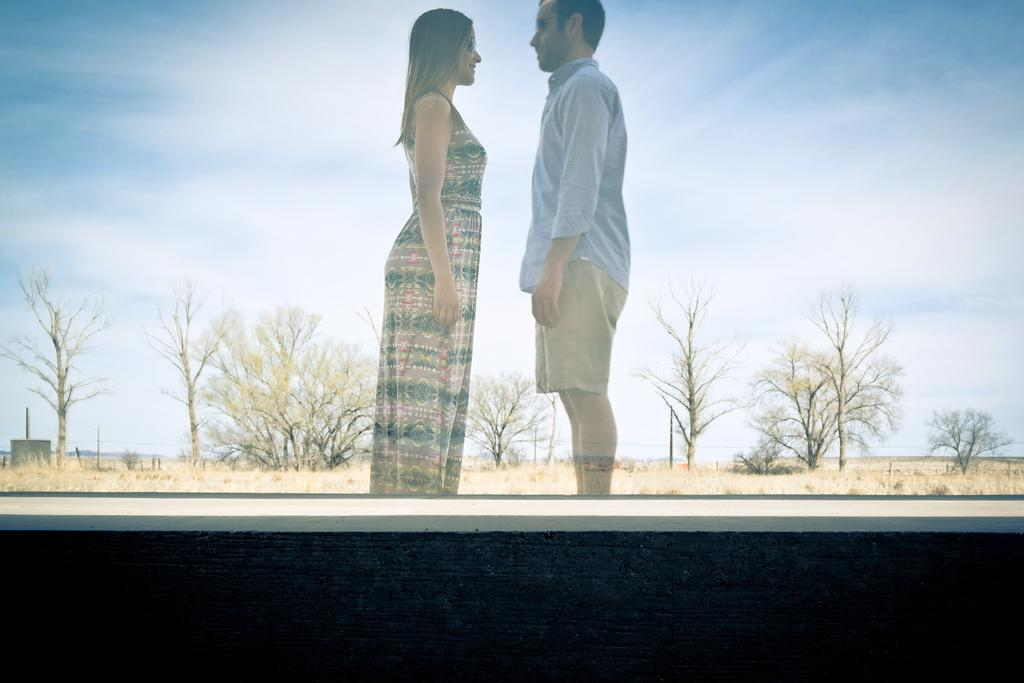Who can be seen in the picture? There is a couple in the picture. What is the couple's position in the image? The couple is standing on the ground. What can be seen in the background of the image? There are trees and the sky visible in the background of the image. What is the condition of the sky in the image? The sky has clouds in the image. What is the minister's reaction to the aftermath of the impulse in the image? There is no minister or impulse present in the image. 